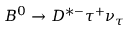<formula> <loc_0><loc_0><loc_500><loc_500>B ^ { 0 } \to D ^ { * - } \tau ^ { + } \nu _ { \tau }</formula> 